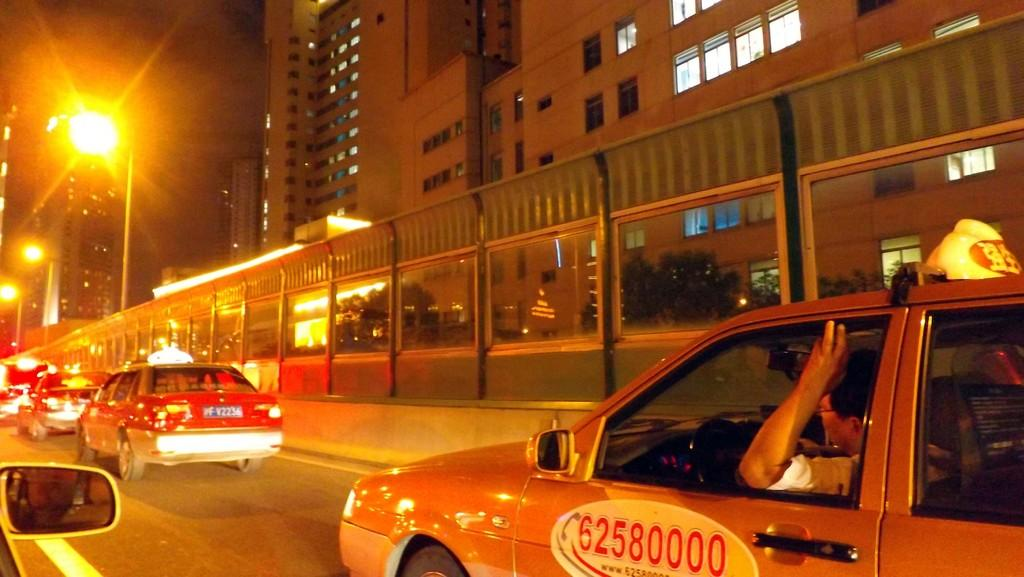<image>
Give a short and clear explanation of the subsequent image. A taxi in traffic with the number 62580000 on the door. 